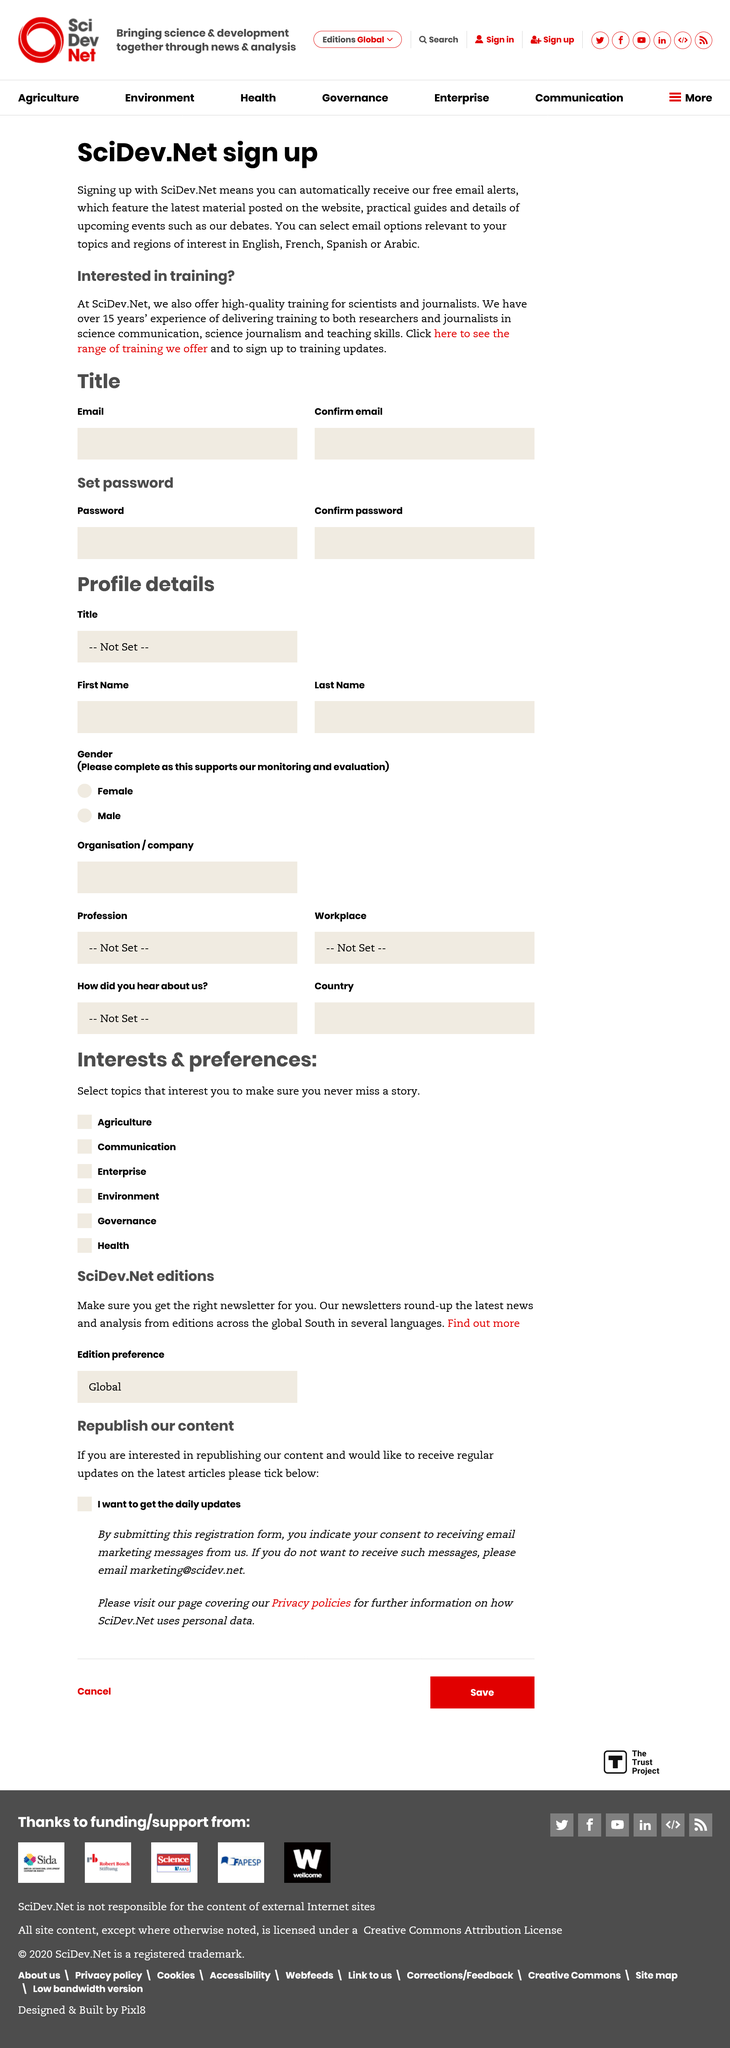Specify some key components in this picture. SciDev.Net has over 15 years of experience in delivering training, not less than 15 years. SciDev.Net's email options can be selected in English, French, Spanish, or Arabic. It is necessary for users to register separately for SciDev.Net's free email alerts and training updates. 